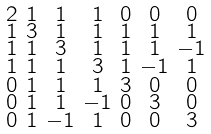<formula> <loc_0><loc_0><loc_500><loc_500>\begin{smallmatrix} 2 & 1 & 1 & 1 & 0 & 0 & 0 \\ 1 & 3 & 1 & 1 & 1 & 1 & 1 \\ 1 & 1 & 3 & 1 & 1 & 1 & - 1 \\ 1 & 1 & 1 & 3 & 1 & - 1 & 1 \\ 0 & 1 & 1 & 1 & 3 & 0 & 0 \\ 0 & 1 & 1 & - 1 & 0 & 3 & 0 \\ 0 & 1 & - 1 & 1 & 0 & 0 & 3 \end{smallmatrix}</formula> 